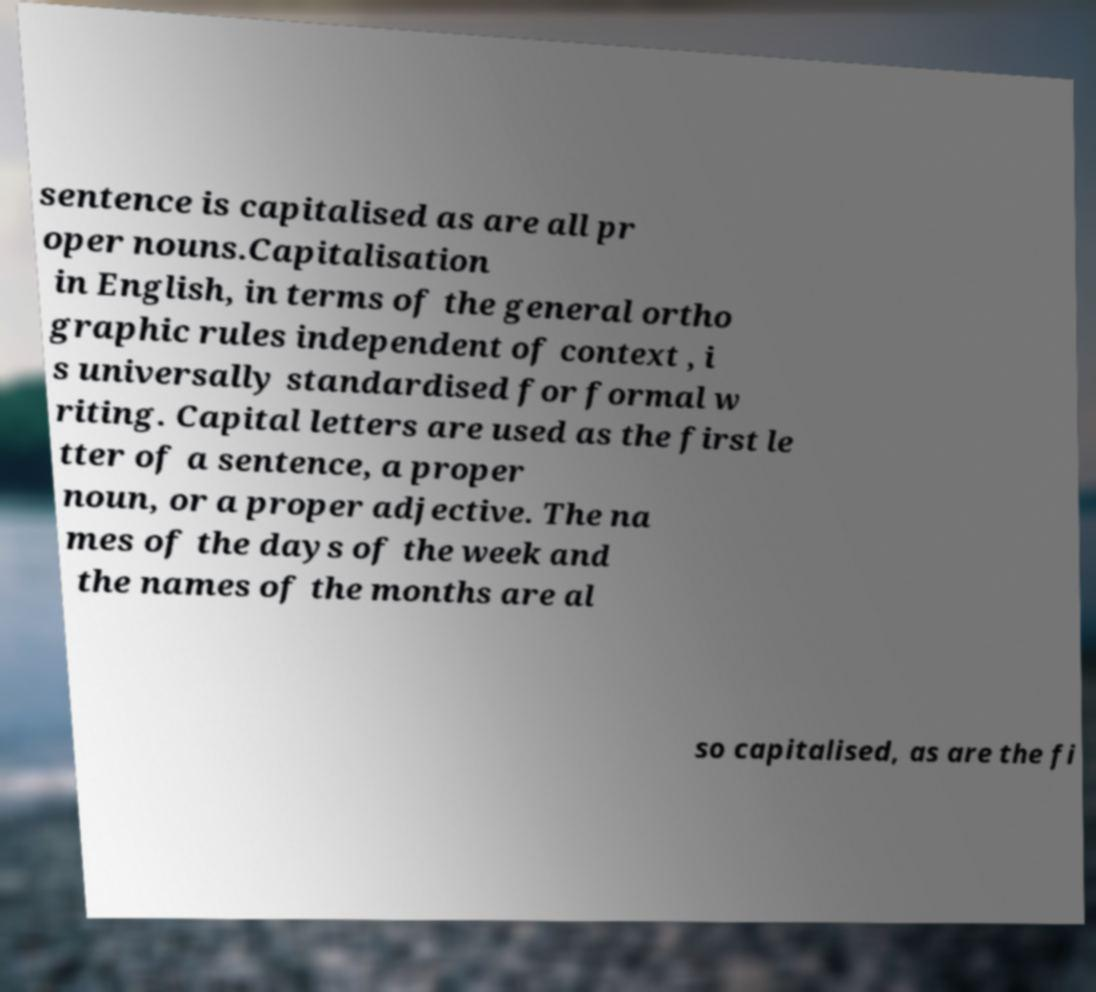Could you extract and type out the text from this image? sentence is capitalised as are all pr oper nouns.Capitalisation in English, in terms of the general ortho graphic rules independent of context , i s universally standardised for formal w riting. Capital letters are used as the first le tter of a sentence, a proper noun, or a proper adjective. The na mes of the days of the week and the names of the months are al so capitalised, as are the fi 